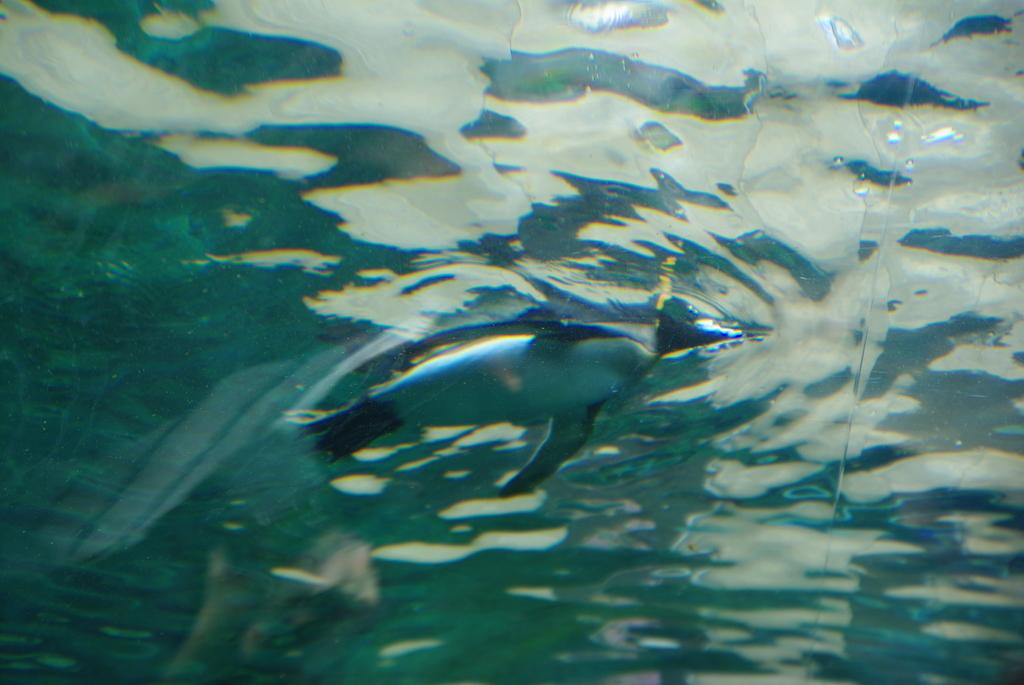What animal is the main subject of the picture? There is a penguin in the picture. What is the penguin doing in the image? The penguin is swimming in the water. What type of lamp is hanging above the penguin in the image? There is no lamp present in the image; it features a penguin swimming in the water. What facial expression does the penguin have in the image? The image does not show the penguin's face, so it is not possible to determine its facial expression. 